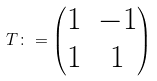<formula> <loc_0><loc_0><loc_500><loc_500>T \colon = \begin{pmatrix} 1 & - 1 \\ 1 & 1 \end{pmatrix}</formula> 